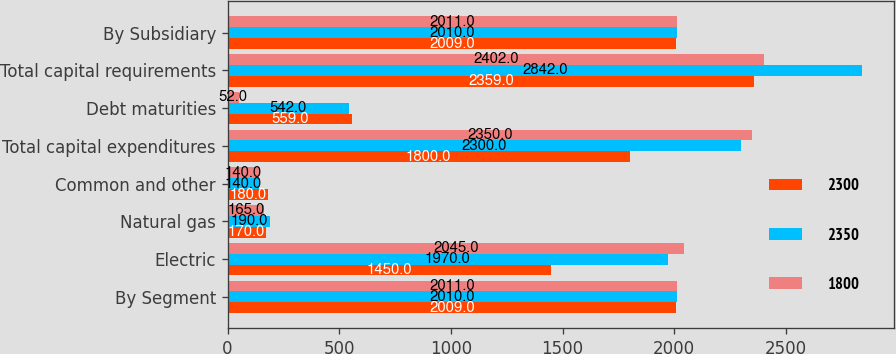Convert chart to OTSL. <chart><loc_0><loc_0><loc_500><loc_500><stacked_bar_chart><ecel><fcel>By Segment<fcel>Electric<fcel>Natural gas<fcel>Common and other<fcel>Total capital expenditures<fcel>Debt maturities<fcel>Total capital requirements<fcel>By Subsidiary<nl><fcel>2300<fcel>2009<fcel>1450<fcel>170<fcel>180<fcel>1800<fcel>559<fcel>2359<fcel>2009<nl><fcel>2350<fcel>2010<fcel>1970<fcel>190<fcel>140<fcel>2300<fcel>542<fcel>2842<fcel>2010<nl><fcel>1800<fcel>2011<fcel>2045<fcel>165<fcel>140<fcel>2350<fcel>52<fcel>2402<fcel>2011<nl></chart> 